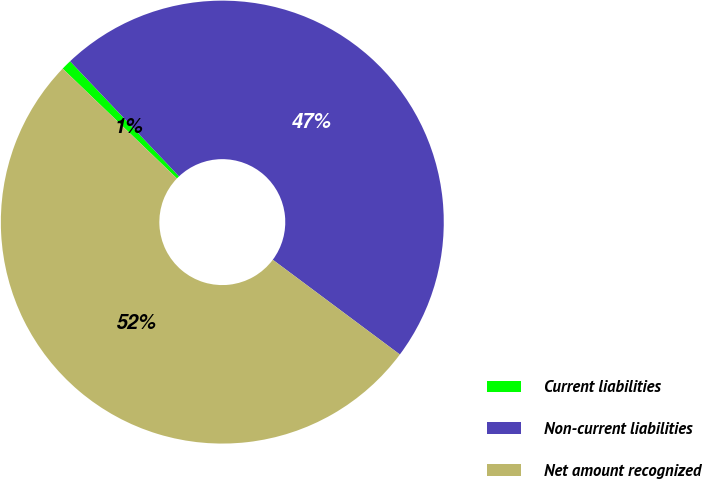Convert chart to OTSL. <chart><loc_0><loc_0><loc_500><loc_500><pie_chart><fcel>Current liabilities<fcel>Non-current liabilities<fcel>Net amount recognized<nl><fcel>0.75%<fcel>47.26%<fcel>51.99%<nl></chart> 